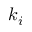Convert formula to latex. <formula><loc_0><loc_0><loc_500><loc_500>k _ { i }</formula> 